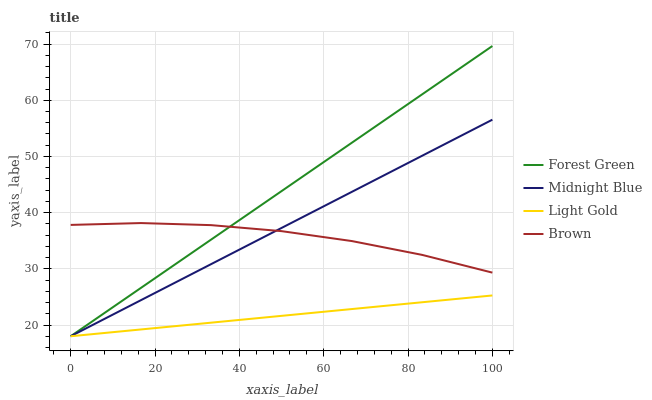Does Light Gold have the minimum area under the curve?
Answer yes or no. Yes. Does Forest Green have the maximum area under the curve?
Answer yes or no. Yes. Does Forest Green have the minimum area under the curve?
Answer yes or no. No. Does Light Gold have the maximum area under the curve?
Answer yes or no. No. Is Light Gold the smoothest?
Answer yes or no. Yes. Is Brown the roughest?
Answer yes or no. Yes. Is Forest Green the smoothest?
Answer yes or no. No. Is Forest Green the roughest?
Answer yes or no. No. Does Forest Green have the lowest value?
Answer yes or no. Yes. Does Forest Green have the highest value?
Answer yes or no. Yes. Does Light Gold have the highest value?
Answer yes or no. No. Is Light Gold less than Brown?
Answer yes or no. Yes. Is Brown greater than Light Gold?
Answer yes or no. Yes. Does Midnight Blue intersect Forest Green?
Answer yes or no. Yes. Is Midnight Blue less than Forest Green?
Answer yes or no. No. Is Midnight Blue greater than Forest Green?
Answer yes or no. No. Does Light Gold intersect Brown?
Answer yes or no. No. 